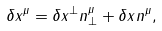Convert formula to latex. <formula><loc_0><loc_0><loc_500><loc_500>\delta x ^ { \mu } = \delta x ^ { \perp } n ^ { \mu } _ { \perp } + \delta x ^ { \| } n ^ { \mu } _ { \| } ,</formula> 